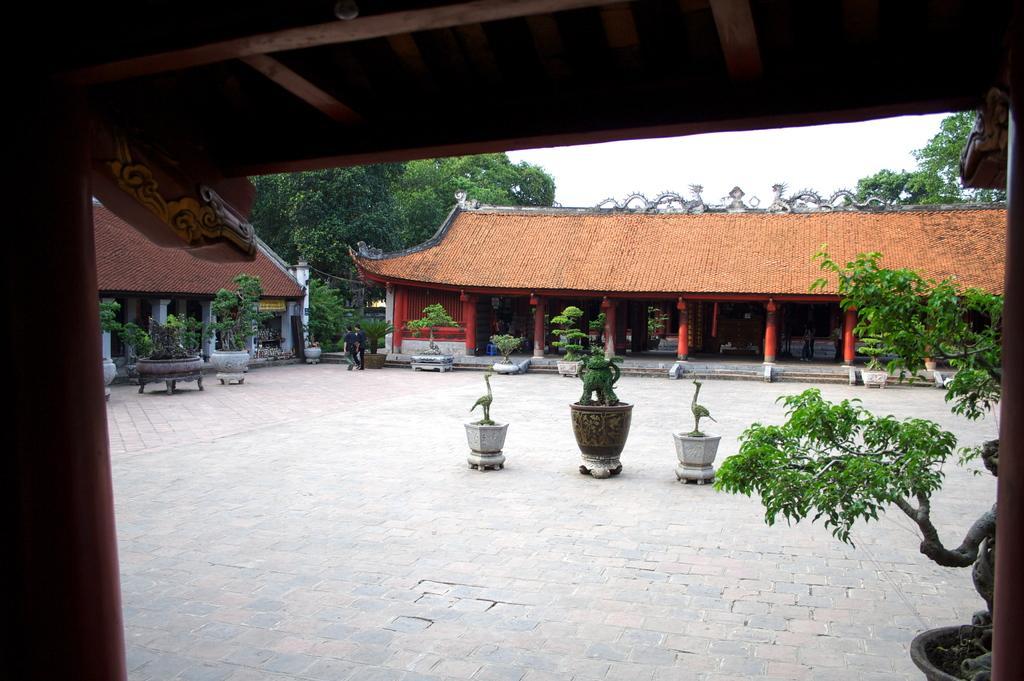Could you give a brief overview of what you see in this image? In this image we can see a clay pot on the right side. Here we can see the decorative statues. Here we can see the trees. Here we can see the houses. Here we can see two persons walking on the floor. In the background, we can see the trees. 